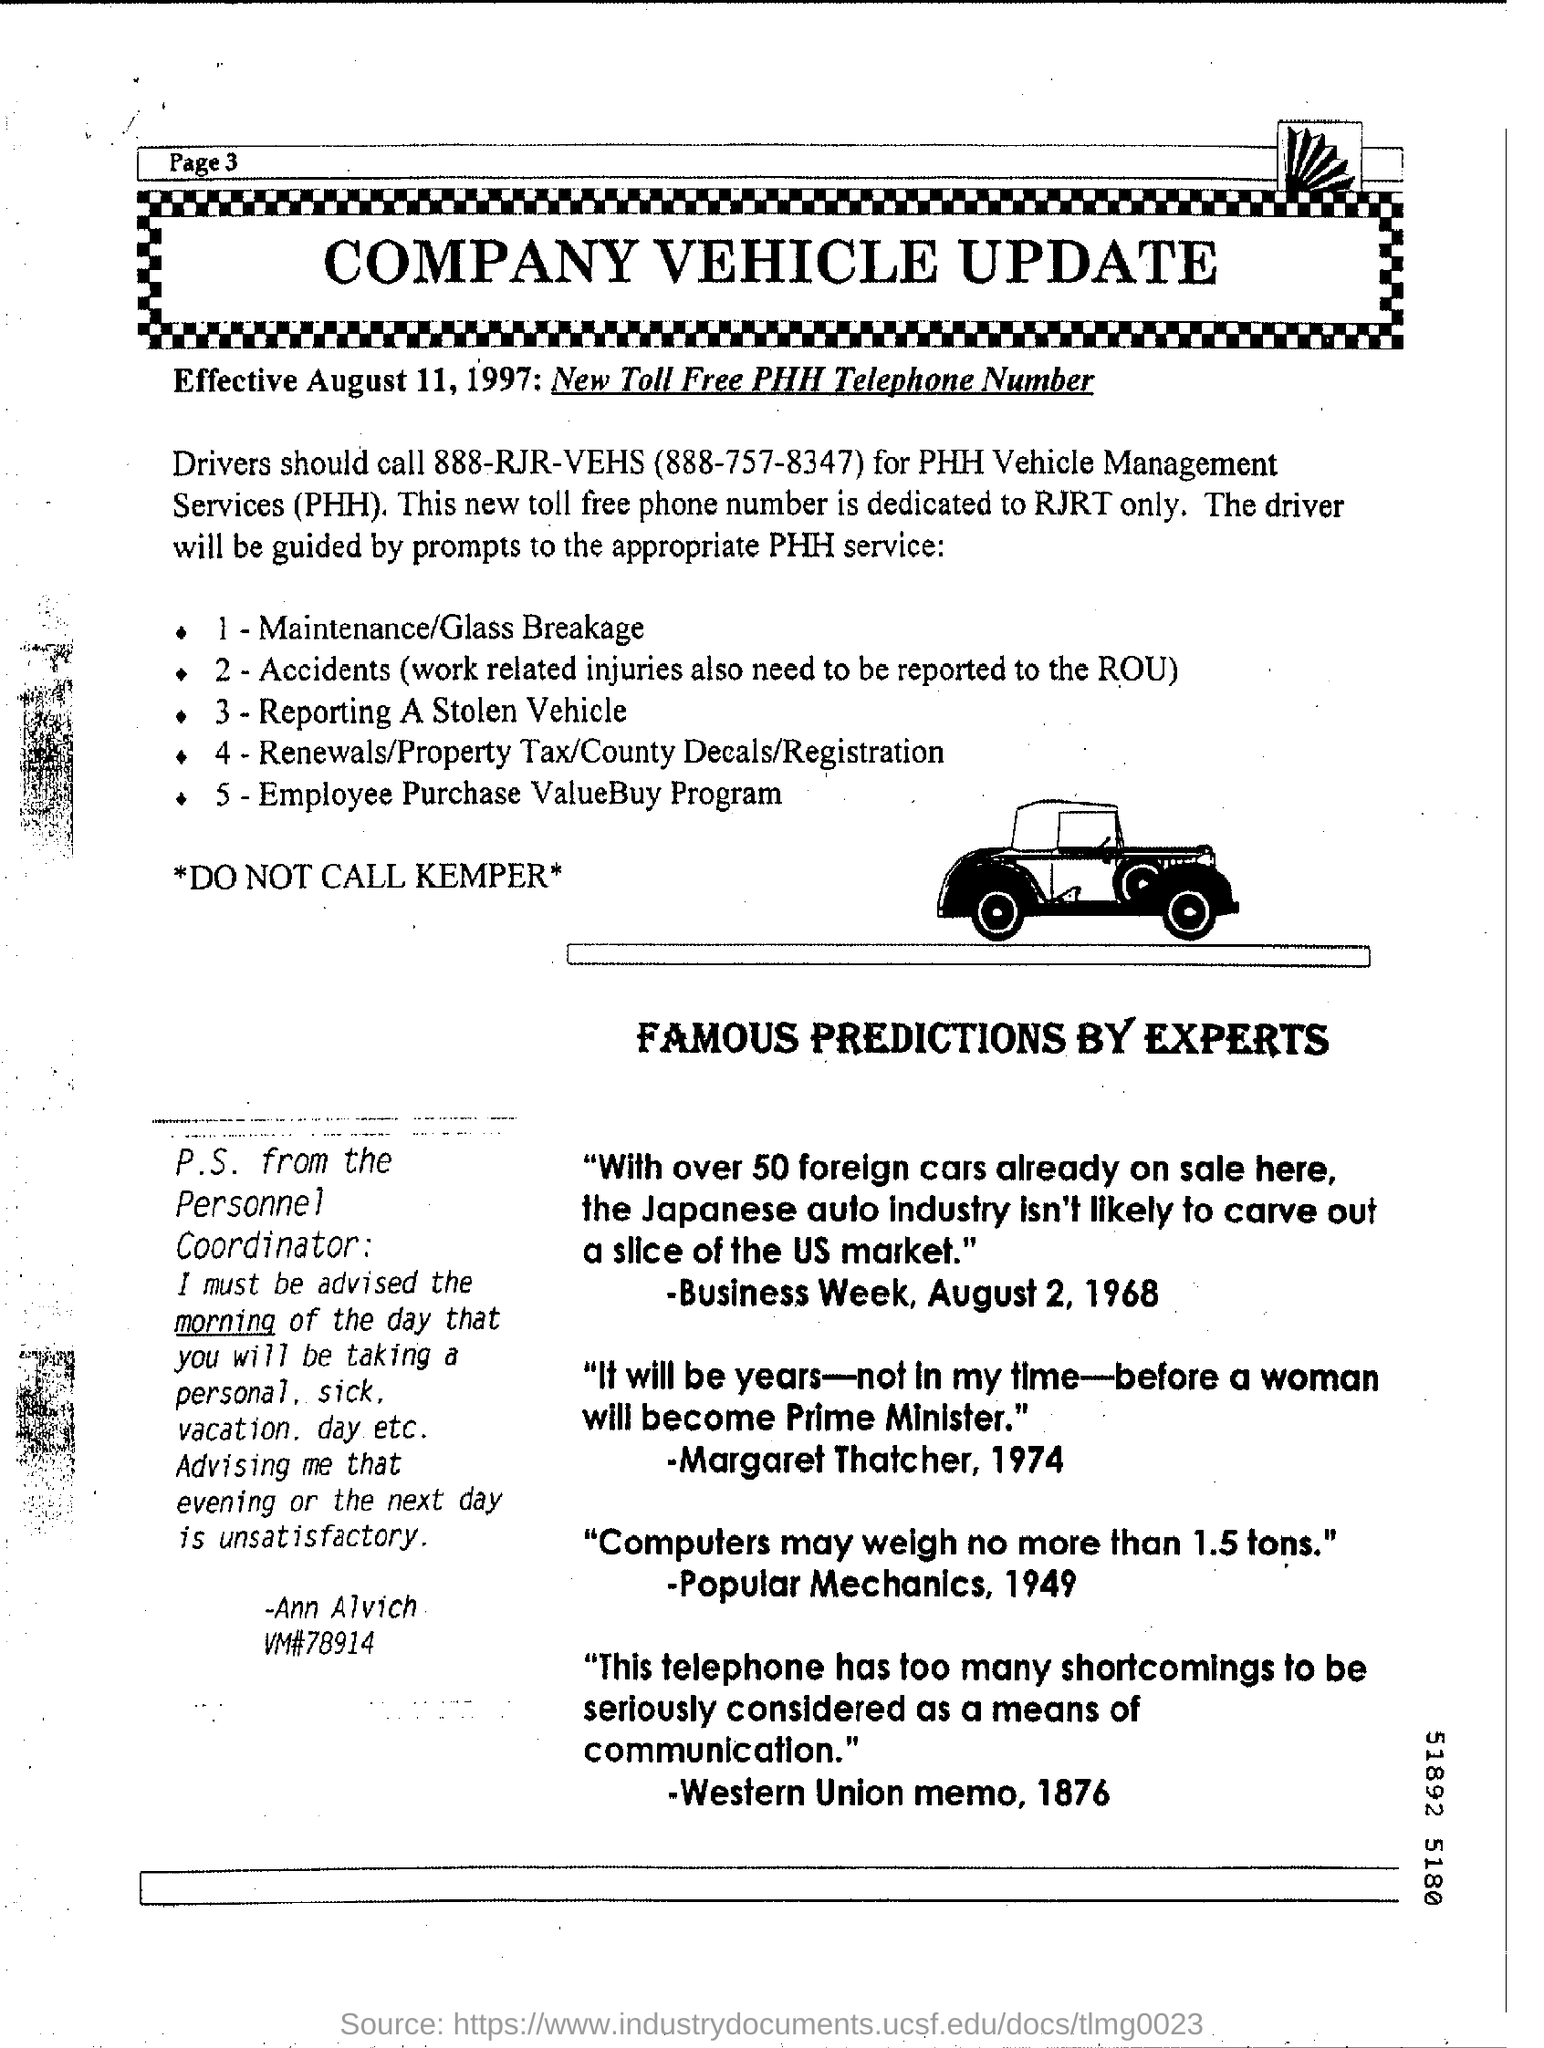Give some essential details in this illustration. Mention the page number at the top left corner of the page, and the number shall be three. 